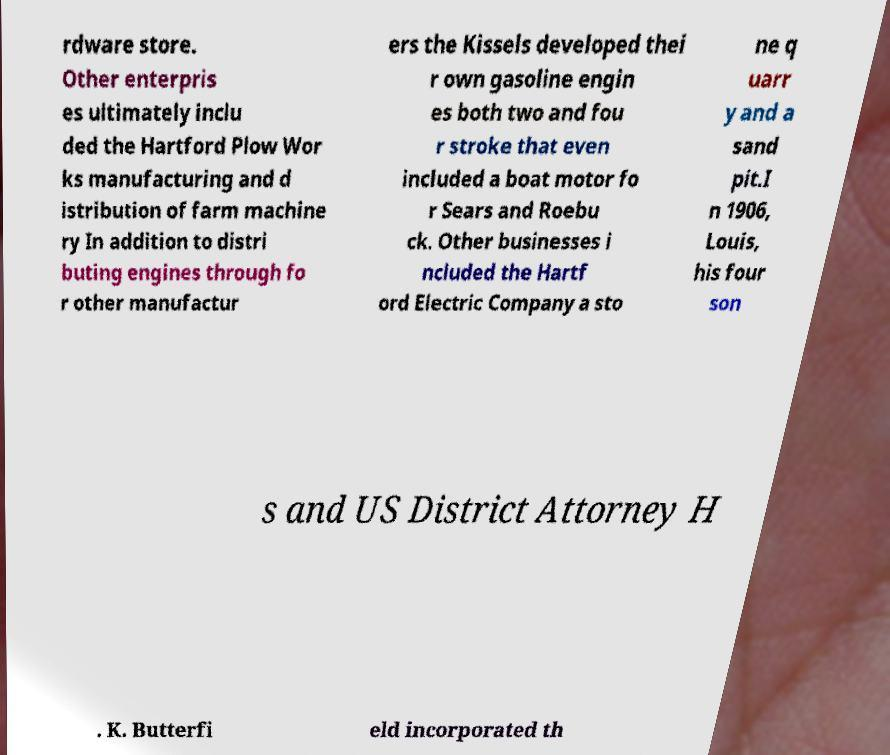What messages or text are displayed in this image? I need them in a readable, typed format. rdware store. Other enterpris es ultimately inclu ded the Hartford Plow Wor ks manufacturing and d istribution of farm machine ry In addition to distri buting engines through fo r other manufactur ers the Kissels developed thei r own gasoline engin es both two and fou r stroke that even included a boat motor fo r Sears and Roebu ck. Other businesses i ncluded the Hartf ord Electric Company a sto ne q uarr y and a sand pit.I n 1906, Louis, his four son s and US District Attorney H . K. Butterfi eld incorporated th 